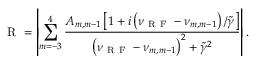Convert formula to latex. <formula><loc_0><loc_0><loc_500><loc_500>R = \left | \sum _ { m = - 3 } ^ { 4 } \frac { A _ { m , m - 1 } \left [ 1 + i \left ( \nu _ { R F } - \nu _ { m , m - 1 } \right ) / \tilde { \gamma } \right ] } { \left ( \nu _ { R F } - \nu _ { m , m - 1 } \right ) ^ { 2 } + \tilde { \gamma } ^ { 2 } } \right | .</formula> 